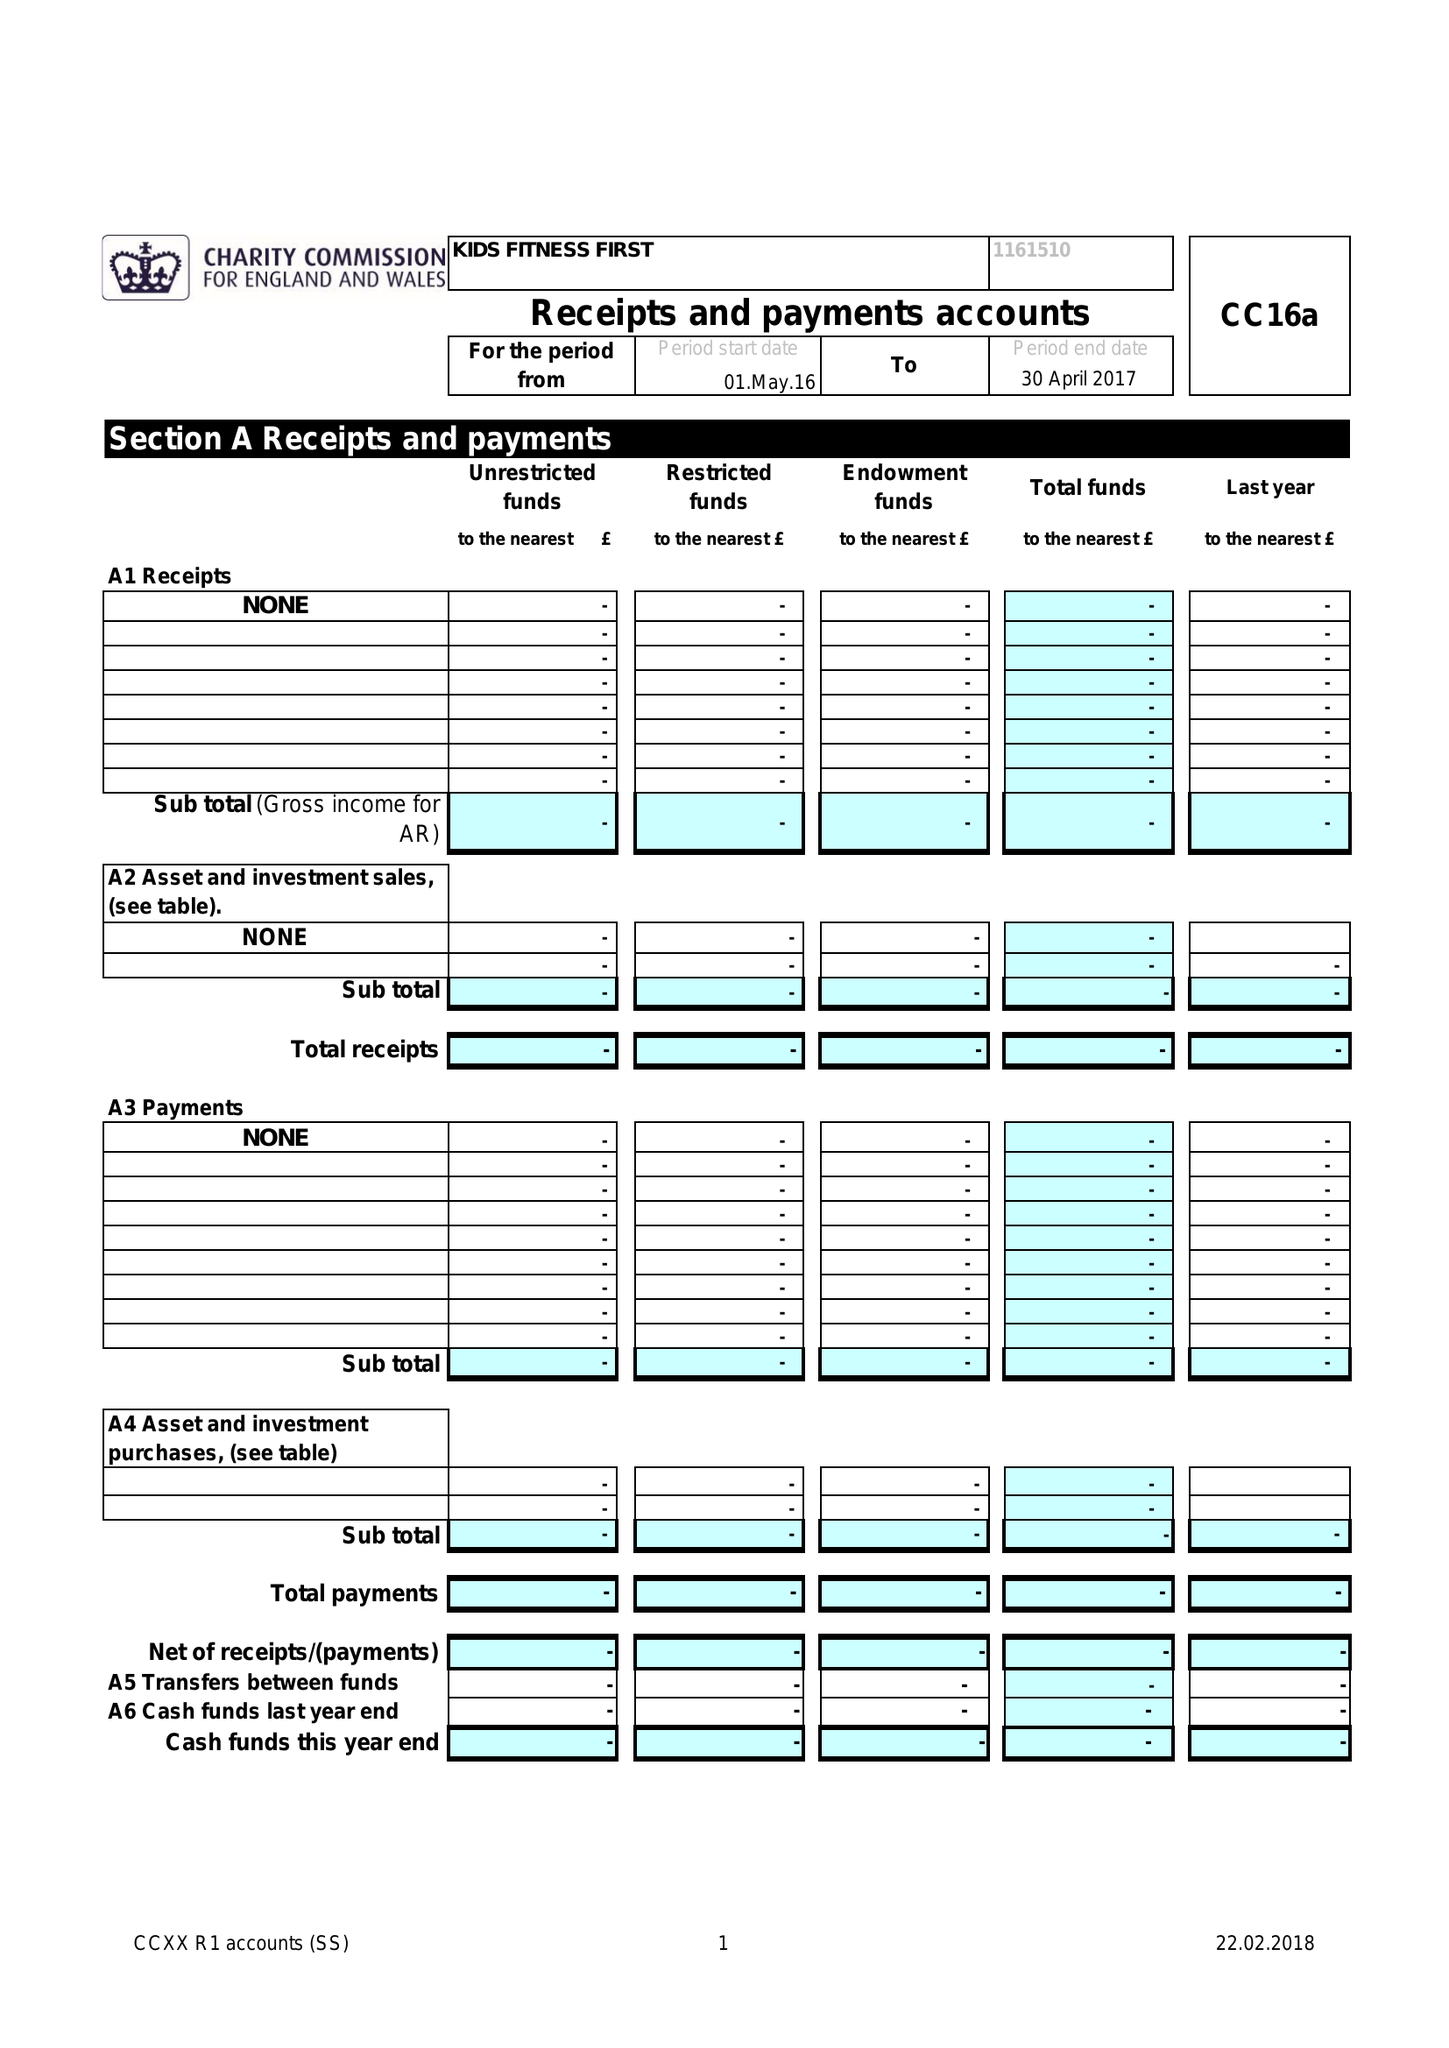What is the value for the charity_number?
Answer the question using a single word or phrase. 1161510 